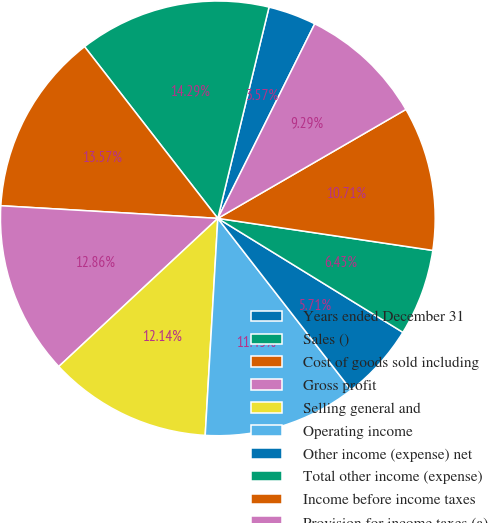Convert chart to OTSL. <chart><loc_0><loc_0><loc_500><loc_500><pie_chart><fcel>Years ended December 31<fcel>Sales ()<fcel>Cost of goods sold including<fcel>Gross profit<fcel>Selling general and<fcel>Operating income<fcel>Other income (expense) net<fcel>Total other income (expense)<fcel>Income before income taxes<fcel>Provision for income taxes (a)<nl><fcel>3.57%<fcel>14.29%<fcel>13.57%<fcel>12.86%<fcel>12.14%<fcel>11.43%<fcel>5.71%<fcel>6.43%<fcel>10.71%<fcel>9.29%<nl></chart> 